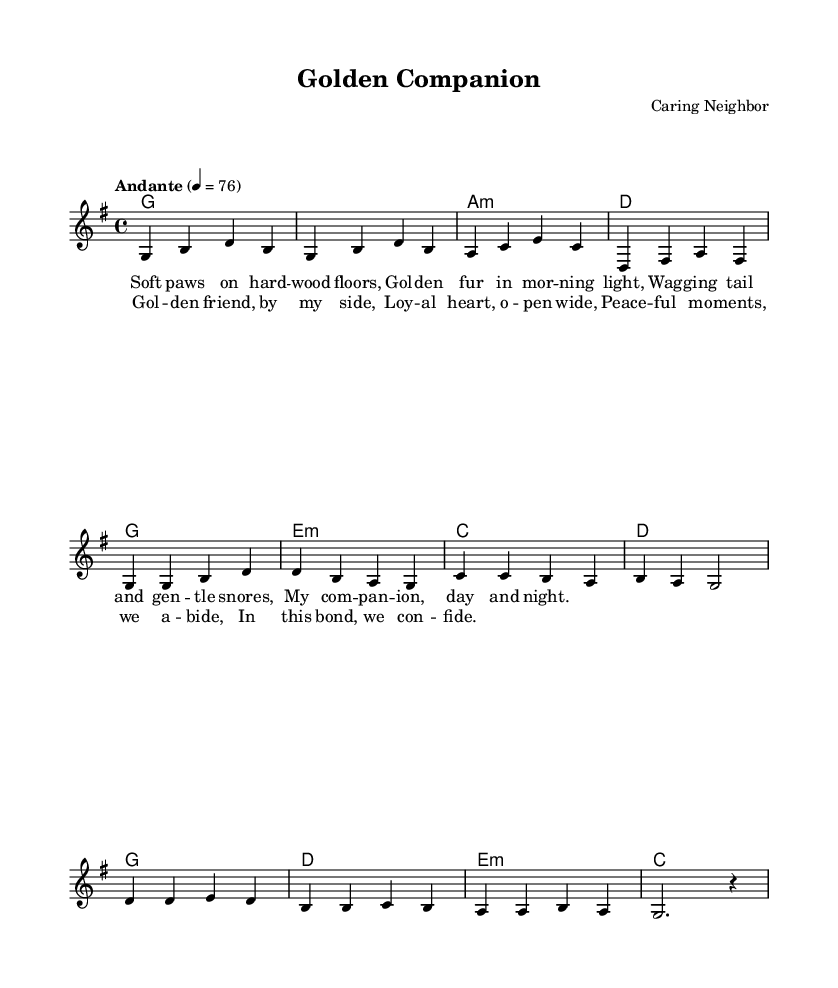What is the key signature of this music? The key signature is indicated at the beginning of the music. It shows one sharp, which means the piece is in G major.
Answer: G major What is the time signature of this music? The time signature is located at the start of the score and shows a "4/4" pattern, meaning there are four beats in each measure.
Answer: 4/4 What is the tempo marking for this piece? The tempo is specified at the beginning of the score, indicating a moderate pace with "Andante" and a metronome marking of 76 beats per minute.
Answer: Andante, 76 How many measures are in the verse section? The verse section is counted by identifying the repeated phrases in the melody and harmonies and there are 12 measures in total within the verse.
Answer: 12 What is the first chord of the song? The first chord is found at the start of the score, under the measure marked as "g1," indicating a G major chord.
Answer: G major How many lines are in the chorus lyrics? The chorus lyrics are structured in four lines. Each line corresponds to a lyrical phrase that describes the bond with the golden retriever.
Answer: 4 What does the term "Loyal heart, open wide" signify in the context of the song? This phrase reflects the emotional connection and trust shared between the dog and the owner, emphasizing companionship and loyalty in their relationship.
Answer: Emotional connection 